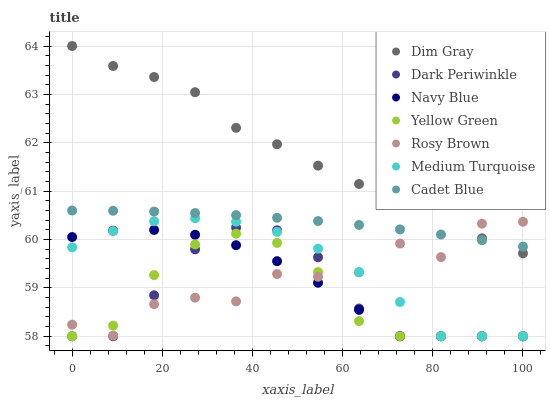Does Yellow Green have the minimum area under the curve?
Answer yes or no. Yes. Does Dim Gray have the maximum area under the curve?
Answer yes or no. Yes. Does Navy Blue have the minimum area under the curve?
Answer yes or no. No. Does Navy Blue have the maximum area under the curve?
Answer yes or no. No. Is Cadet Blue the smoothest?
Answer yes or no. Yes. Is Rosy Brown the roughest?
Answer yes or no. Yes. Is Yellow Green the smoothest?
Answer yes or no. No. Is Yellow Green the roughest?
Answer yes or no. No. Does Yellow Green have the lowest value?
Answer yes or no. Yes. Does Rosy Brown have the lowest value?
Answer yes or no. No. Does Dim Gray have the highest value?
Answer yes or no. Yes. Does Navy Blue have the highest value?
Answer yes or no. No. Is Dark Periwinkle less than Cadet Blue?
Answer yes or no. Yes. Is Dim Gray greater than Yellow Green?
Answer yes or no. Yes. Does Dark Periwinkle intersect Yellow Green?
Answer yes or no. Yes. Is Dark Periwinkle less than Yellow Green?
Answer yes or no. No. Is Dark Periwinkle greater than Yellow Green?
Answer yes or no. No. Does Dark Periwinkle intersect Cadet Blue?
Answer yes or no. No. 